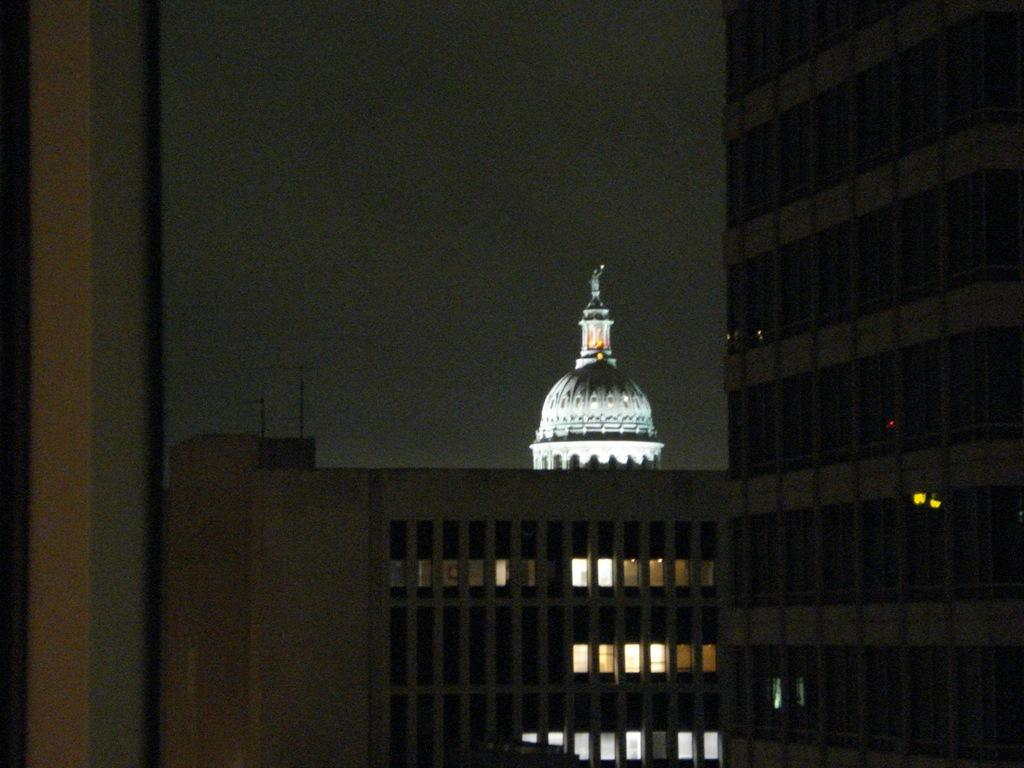What type of structures can be seen in the image? There are buildings in the image. What is the condition of the sky in the image? The sky is dark in the image. What is the income of the people living in the buildings in the image? There is no information about the income of the people living in the buildings in the image. How much respect is shown towards the buildings in the image? There is no indication of the level of respect shown towards the buildings in the image. 